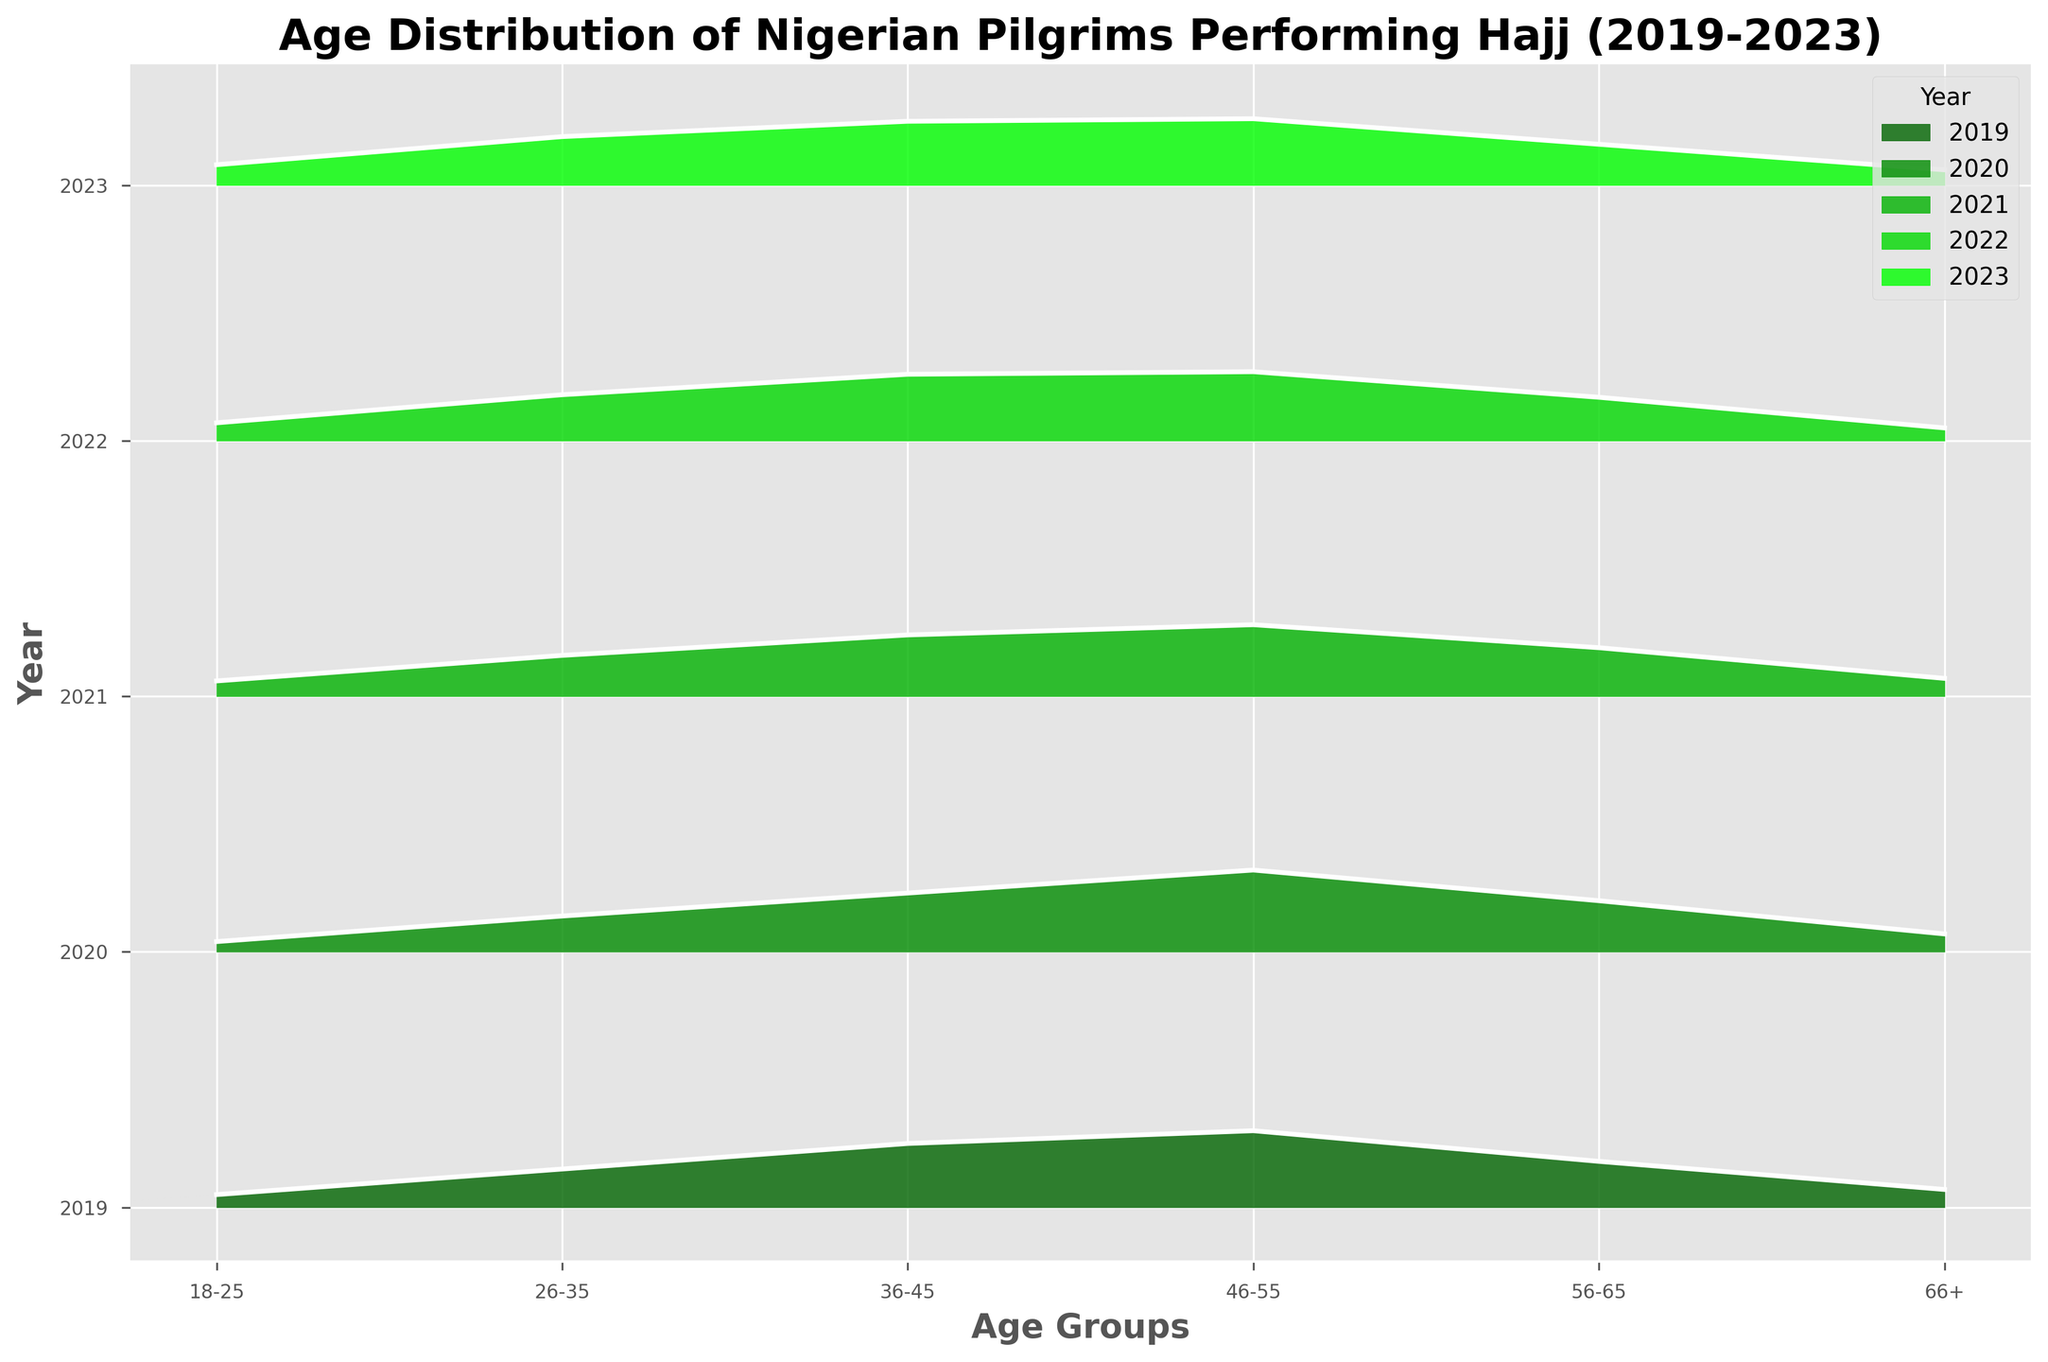Which year has the highest density of pilgrims in the age group 46-55? By examining the height of the filled area for the age group 46-55 across all years, we find that 2020 has the highest density at 0.32.
Answer: 2020 What is the title of the plot? The title is usually displayed at the top of the plot in a bold and larger font.
Answer: Age Distribution of Nigerian Pilgrims Performing Hajj (2019-2023) Which age group consistently has the lowest density across all years? By comparing the densities of each age group across the years, the age group 66+ has the lowest density values throughout all years.
Answer: 66+ How does the density of pilgrims aged 18-25 change from 2019 to 2023? Comparing the densities for the 18-25 age group for each year: 0.05 (2019), 0.04 (2020), 0.06 (2021), 0.07 (2022), and 0.08 (2023), we see an overall increase over time.
Answer: It increases Which year has the highest overall density for pilgrims aged 56-65? By looking at the densities for the 56-65 age group across the years: 0.18 (2019), 0.20 (2020), 0.19 (2021), 0.17 (2022), and 0.16 (2023), the highest density is in 2020 at 0.20.
Answer: 2020 In which year did the age group 26-35 have the highest density? Analyzing the densities for the age group 26-35 across the years: 0.15 (2019), 0.14 (2020), 0.16 (2021), 0.18 (2022), and 0.19 (2023), the highest value is 0.19 in 2023.
Answer: 2023 What age group had the highest density in 2022? For 2022, the age groups have densities: 18-25 (0.07), 26-35 (0.18), 36-45 (0.26), 46-55 (0.27), 56-65 (0.17), and 66+ (0.05). The age group 46-55 has the highest density of 0.27.
Answer: 46-55 What is the difference in density between the age groups 26-35 and 36-45 in 2023? For 2023, the densities are 0.19 (26-35) and 0.25 (36-45). Subtracting, we get 0.25 - 0.19 = 0.06.
Answer: 0.06 Explain the pattern of the age group 46-55 over the years 2019-2023. By examining the densities for the age group 46-55 over the years: 0.30 (2019), 0.32 (2020), 0.28 (2021), 0.27 (2022), and 0.26 (2023), there's a slight decrease after 2020.
Answer: Decreases slightly after 2020 